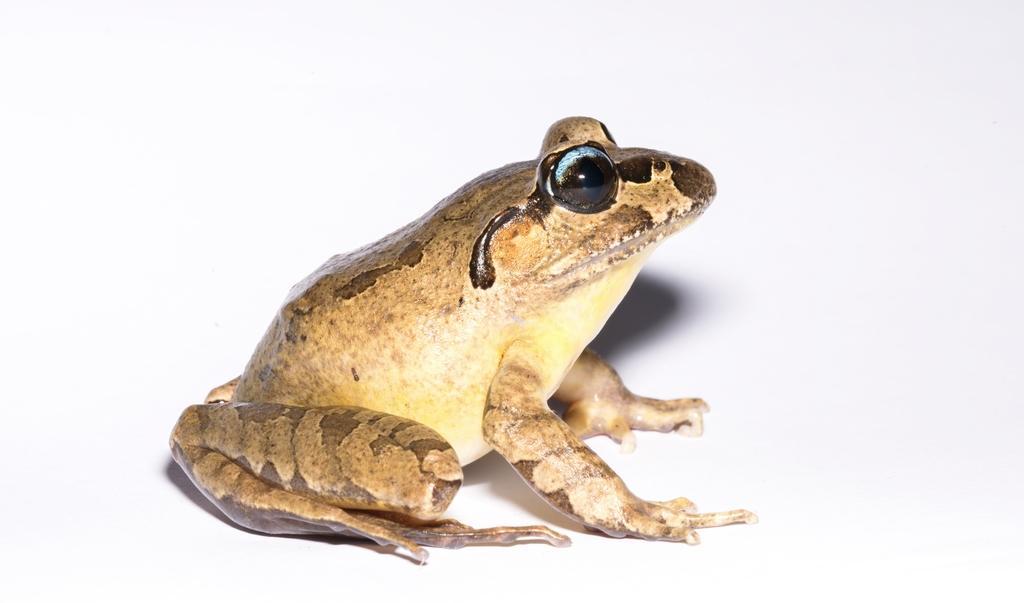Could you give a brief overview of what you see in this image? In this image, we can see a frog. In the background, we can see white color. 